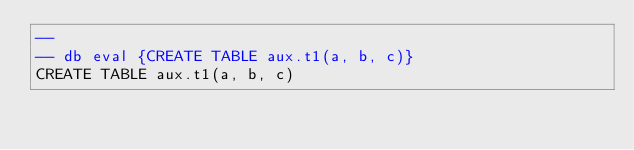Convert code to text. <code><loc_0><loc_0><loc_500><loc_500><_SQL_>-- 
-- db eval {CREATE TABLE aux.t1(a, b, c)}
CREATE TABLE aux.t1(a, b, c)</code> 